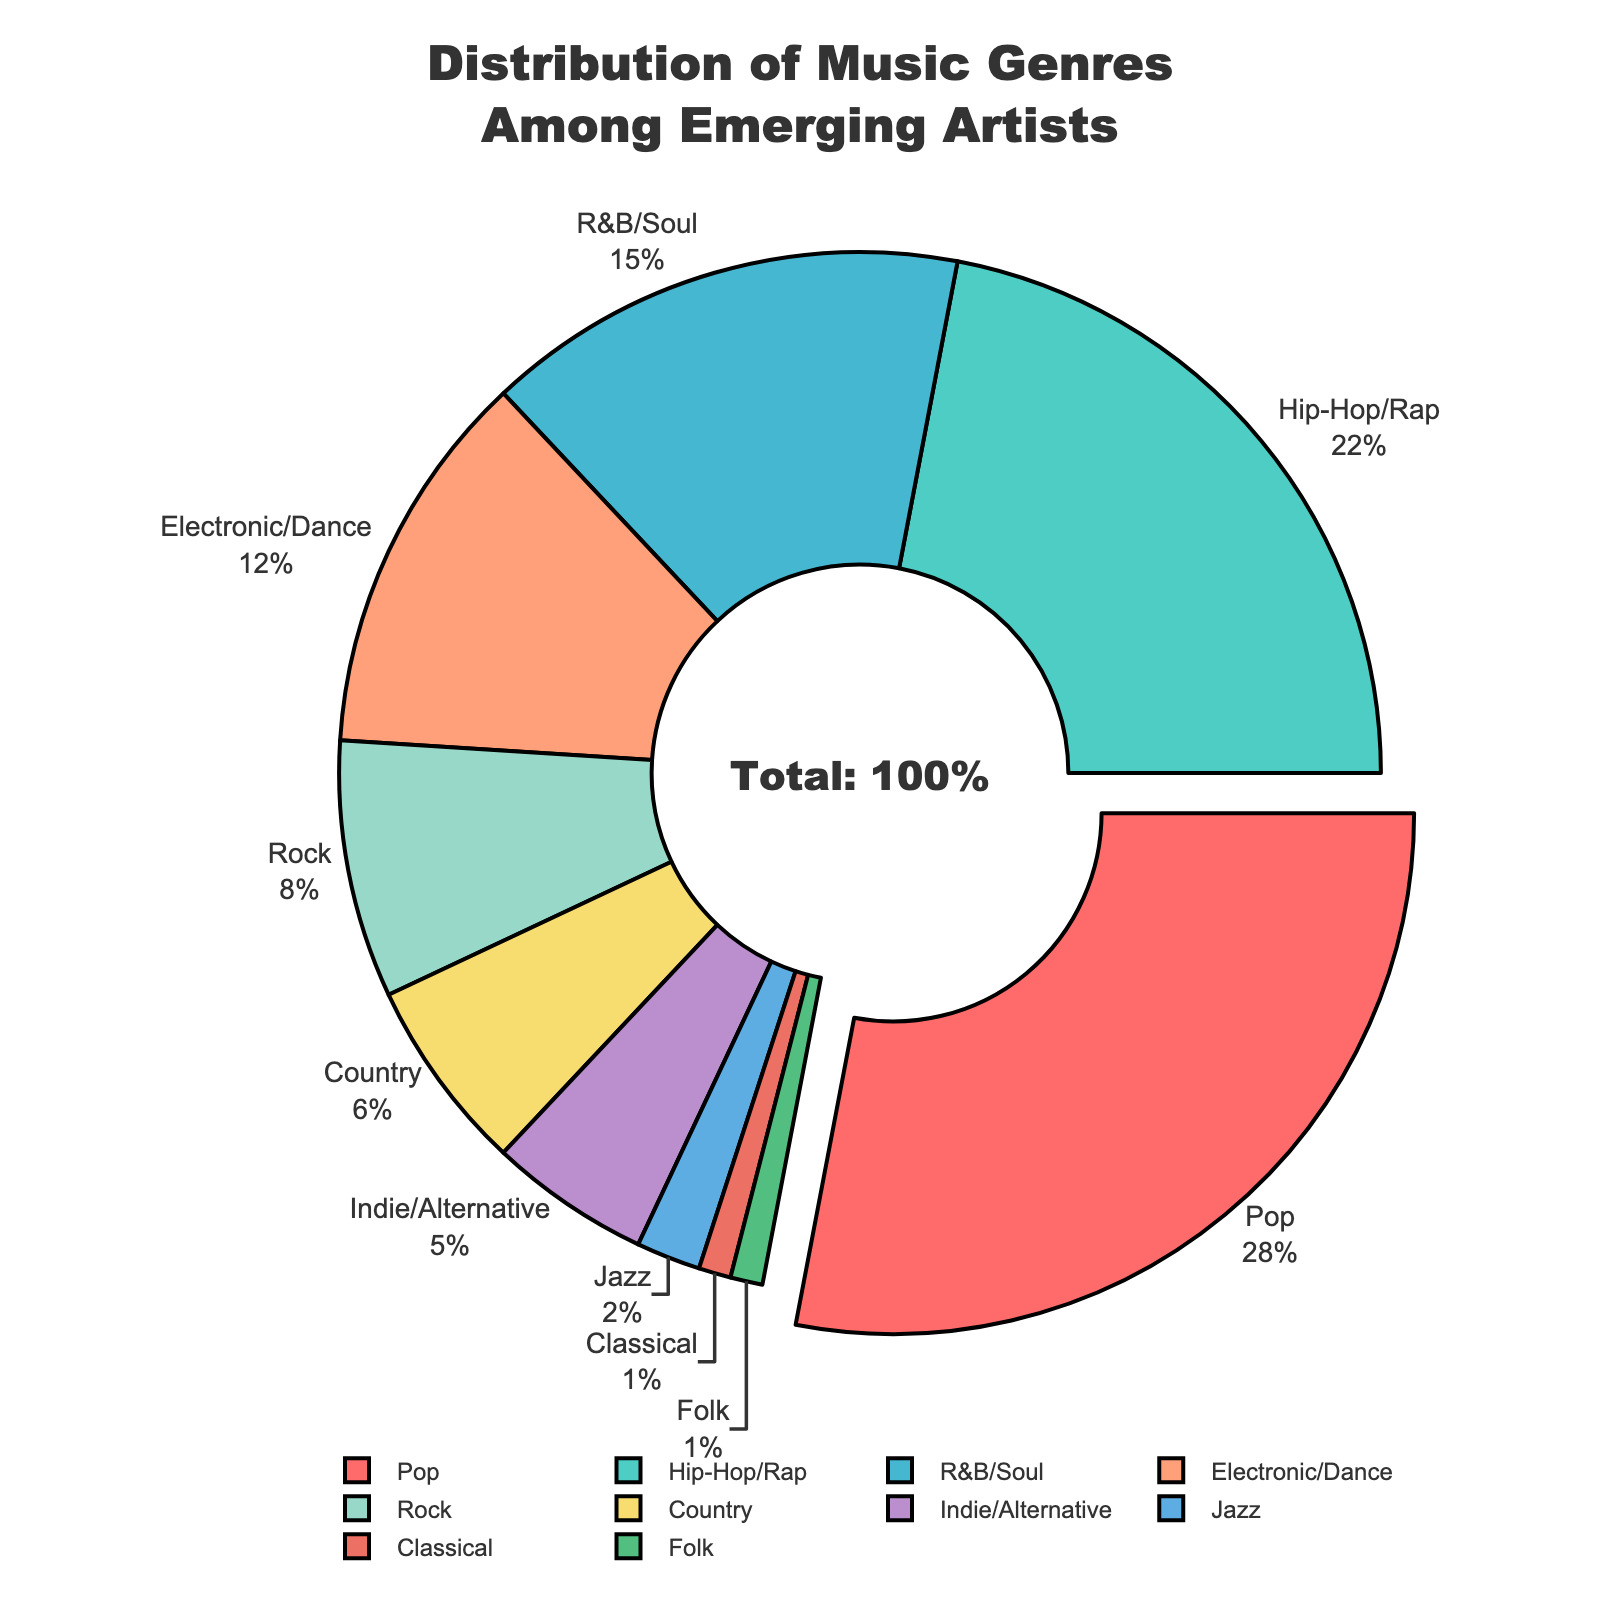What's the most popular music genre among emerging artists? The pie chart shows the distribution of music genres among emerging artists with the percentages. The largest section of the pie chart is labeled "Pop" with 28%.
Answer: Pop What is the combined percentage of Indie/Alternative and Jazz genres? The percentage for Indie/Alternative is 5% and for Jazz, it is 2%. The combined percentage is calculated as 5% + 2% = 7%.
Answer: 7% Which genre has twice the percentage of Country music? Country music has a percentage of 6%. The genre that has twice this percentage is Hip-Hop/Rap, which has 22%. Although 12% (which is twice 6%) is also valid, only a 22% value exists that is twice as much in the given categories.
Answer: Hip-Hop/Rap Which sections of the pie chart are visually the smallest? The smallest sections of the pie chart are labeled "Classical" and "Folk", each with 1%.
Answer: Classical and Folk How much larger is the percentage of Pop compared to Electronic/Dance? The percentage for Pop is 28% and for Electronic/Dance it is 12%. The difference is calculated as 28% - 12% = 16%.
Answer: 16% What percentage of emerging artists fall into genres that have at least 10% representation? The genres with at least 10% are Pop (28%), Hip-Hop/Rap (22%), R&B/Soul (15%), and Electronic/Dance (12%). Adding these gives 28% + 22% + 15% + 12% = 77%.
Answer: 77% Are there more emerging artists in the Rock genre or the R&B/Soul genre? The percentage of emerging artists in the Rock genre is 8% and in the R&B/Soul genre is 15%. Therefore, R&B/Soul has a larger percentage.
Answer: R&B/Soul Which genre has the smallest section in the pie chart? Both Classical and Folk genres have the smallest sections in the pie chart, each with 1%.
Answer: Classical and Folk By how much does the Hip-Hop/Rap portion exceed the Rock portion? The percentage for Hip-Hop/Rap is 22% and for Rock it is 8%. The difference is calculated as 22% - 8% = 14%.
Answer: 14% What is the collective percentage of all genres that are part of the pie chart but are not Pop, Hip-Hop/Rap, or R&B/Soul? The percentages for Pop, Hip-Hop/Rap, and R&B/Soul are 28%, 22%, and 15%, respectively. The collective percentage of genres that are not these three is calculated by first summing these three: 28% + 22% + 15% = 65%. Then, subtract from 100%: 100% - 65% = 35%.
Answer: 35% 